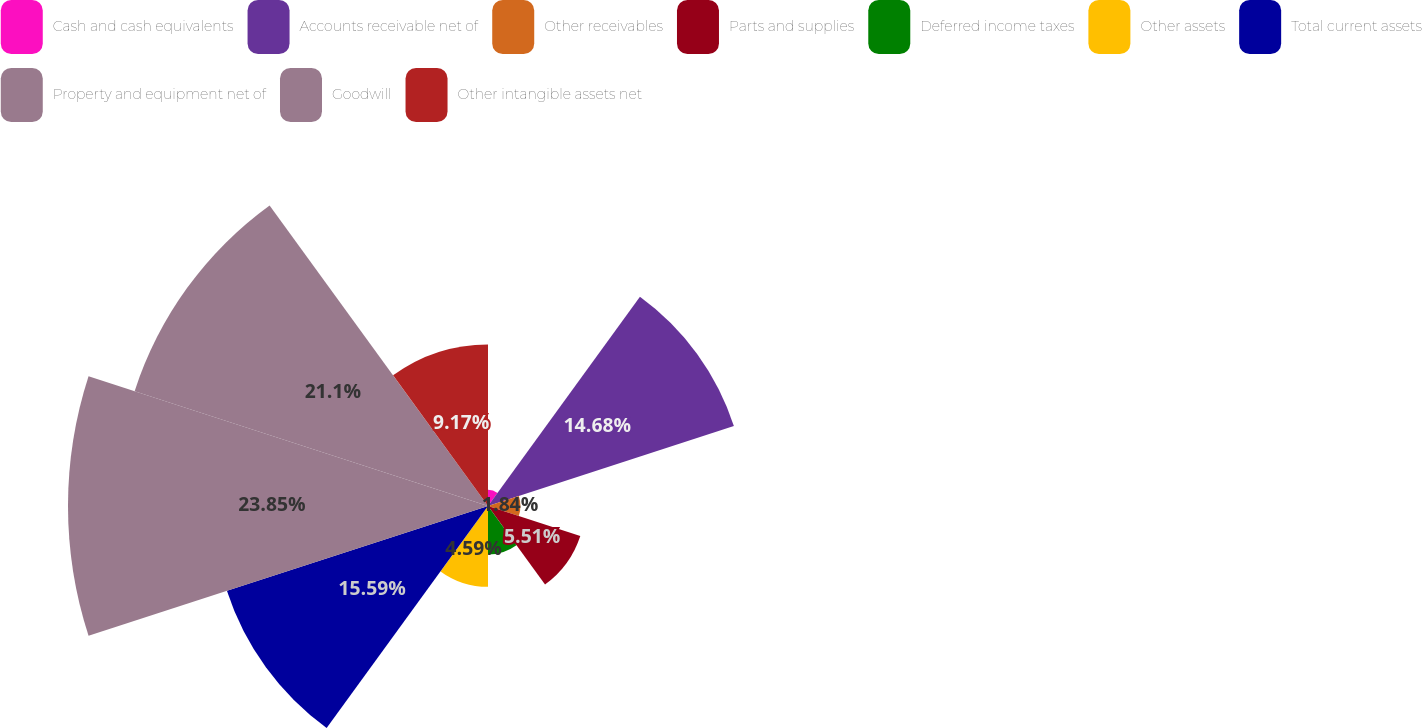<chart> <loc_0><loc_0><loc_500><loc_500><pie_chart><fcel>Cash and cash equivalents<fcel>Accounts receivable net of<fcel>Other receivables<fcel>Parts and supplies<fcel>Deferred income taxes<fcel>Other assets<fcel>Total current assets<fcel>Property and equipment net of<fcel>Goodwill<fcel>Other intangible assets net<nl><fcel>0.92%<fcel>14.68%<fcel>1.84%<fcel>5.51%<fcel>2.75%<fcel>4.59%<fcel>15.59%<fcel>23.85%<fcel>21.1%<fcel>9.17%<nl></chart> 